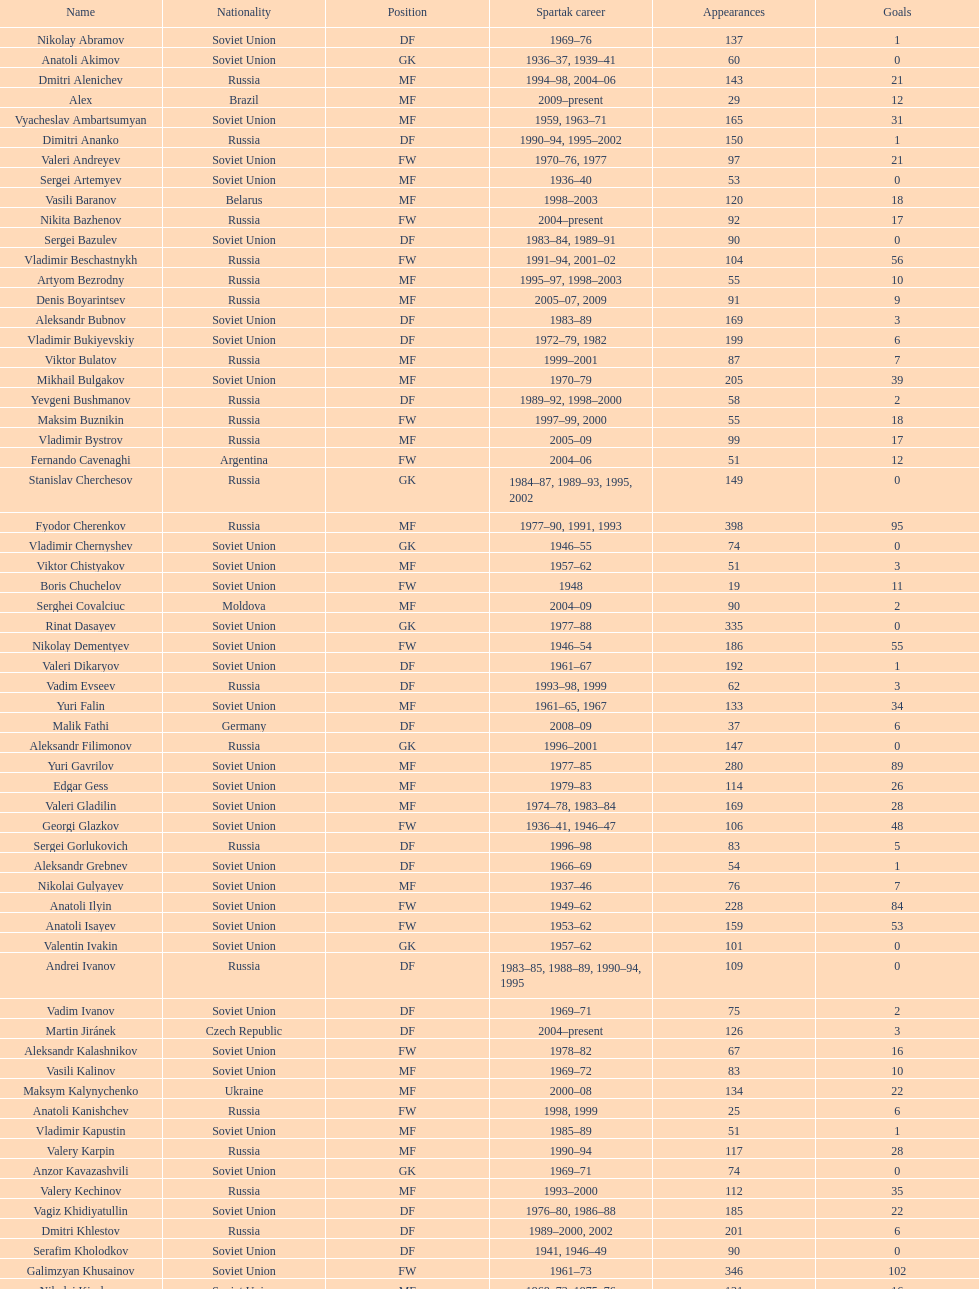Would you mind parsing the complete table? {'header': ['Name', 'Nationality', 'Position', 'Spartak career', 'Appearances', 'Goals'], 'rows': [['Nikolay Abramov', 'Soviet Union', 'DF', '1969–76', '137', '1'], ['Anatoli Akimov', 'Soviet Union', 'GK', '1936–37, 1939–41', '60', '0'], ['Dmitri Alenichev', 'Russia', 'MF', '1994–98, 2004–06', '143', '21'], ['Alex', 'Brazil', 'MF', '2009–present', '29', '12'], ['Vyacheslav Ambartsumyan', 'Soviet Union', 'MF', '1959, 1963–71', '165', '31'], ['Dimitri Ananko', 'Russia', 'DF', '1990–94, 1995–2002', '150', '1'], ['Valeri Andreyev', 'Soviet Union', 'FW', '1970–76, 1977', '97', '21'], ['Sergei Artemyev', 'Soviet Union', 'MF', '1936–40', '53', '0'], ['Vasili Baranov', 'Belarus', 'MF', '1998–2003', '120', '18'], ['Nikita Bazhenov', 'Russia', 'FW', '2004–present', '92', '17'], ['Sergei Bazulev', 'Soviet Union', 'DF', '1983–84, 1989–91', '90', '0'], ['Vladimir Beschastnykh', 'Russia', 'FW', '1991–94, 2001–02', '104', '56'], ['Artyom Bezrodny', 'Russia', 'MF', '1995–97, 1998–2003', '55', '10'], ['Denis Boyarintsev', 'Russia', 'MF', '2005–07, 2009', '91', '9'], ['Aleksandr Bubnov', 'Soviet Union', 'DF', '1983–89', '169', '3'], ['Vladimir Bukiyevskiy', 'Soviet Union', 'DF', '1972–79, 1982', '199', '6'], ['Viktor Bulatov', 'Russia', 'MF', '1999–2001', '87', '7'], ['Mikhail Bulgakov', 'Soviet Union', 'MF', '1970–79', '205', '39'], ['Yevgeni Bushmanov', 'Russia', 'DF', '1989–92, 1998–2000', '58', '2'], ['Maksim Buznikin', 'Russia', 'FW', '1997–99, 2000', '55', '18'], ['Vladimir Bystrov', 'Russia', 'MF', '2005–09', '99', '17'], ['Fernando Cavenaghi', 'Argentina', 'FW', '2004–06', '51', '12'], ['Stanislav Cherchesov', 'Russia', 'GK', '1984–87, 1989–93, 1995, 2002', '149', '0'], ['Fyodor Cherenkov', 'Russia', 'MF', '1977–90, 1991, 1993', '398', '95'], ['Vladimir Chernyshev', 'Soviet Union', 'GK', '1946–55', '74', '0'], ['Viktor Chistyakov', 'Soviet Union', 'MF', '1957–62', '51', '3'], ['Boris Chuchelov', 'Soviet Union', 'FW', '1948', '19', '11'], ['Serghei Covalciuc', 'Moldova', 'MF', '2004–09', '90', '2'], ['Rinat Dasayev', 'Soviet Union', 'GK', '1977–88', '335', '0'], ['Nikolay Dementyev', 'Soviet Union', 'FW', '1946–54', '186', '55'], ['Valeri Dikaryov', 'Soviet Union', 'DF', '1961–67', '192', '1'], ['Vadim Evseev', 'Russia', 'DF', '1993–98, 1999', '62', '3'], ['Yuri Falin', 'Soviet Union', 'MF', '1961–65, 1967', '133', '34'], ['Malik Fathi', 'Germany', 'DF', '2008–09', '37', '6'], ['Aleksandr Filimonov', 'Russia', 'GK', '1996–2001', '147', '0'], ['Yuri Gavrilov', 'Soviet Union', 'MF', '1977–85', '280', '89'], ['Edgar Gess', 'Soviet Union', 'MF', '1979–83', '114', '26'], ['Valeri Gladilin', 'Soviet Union', 'MF', '1974–78, 1983–84', '169', '28'], ['Georgi Glazkov', 'Soviet Union', 'FW', '1936–41, 1946–47', '106', '48'], ['Sergei Gorlukovich', 'Russia', 'DF', '1996–98', '83', '5'], ['Aleksandr Grebnev', 'Soviet Union', 'DF', '1966–69', '54', '1'], ['Nikolai Gulyayev', 'Soviet Union', 'MF', '1937–46', '76', '7'], ['Anatoli Ilyin', 'Soviet Union', 'FW', '1949–62', '228', '84'], ['Anatoli Isayev', 'Soviet Union', 'FW', '1953–62', '159', '53'], ['Valentin Ivakin', 'Soviet Union', 'GK', '1957–62', '101', '0'], ['Andrei Ivanov', 'Russia', 'DF', '1983–85, 1988–89, 1990–94, 1995', '109', '0'], ['Vadim Ivanov', 'Soviet Union', 'DF', '1969–71', '75', '2'], ['Martin Jiránek', 'Czech Republic', 'DF', '2004–present', '126', '3'], ['Aleksandr Kalashnikov', 'Soviet Union', 'FW', '1978–82', '67', '16'], ['Vasili Kalinov', 'Soviet Union', 'MF', '1969–72', '83', '10'], ['Maksym Kalynychenko', 'Ukraine', 'MF', '2000–08', '134', '22'], ['Anatoli Kanishchev', 'Russia', 'FW', '1998, 1999', '25', '6'], ['Vladimir Kapustin', 'Soviet Union', 'MF', '1985–89', '51', '1'], ['Valery Karpin', 'Russia', 'MF', '1990–94', '117', '28'], ['Anzor Kavazashvili', 'Soviet Union', 'GK', '1969–71', '74', '0'], ['Valery Kechinov', 'Russia', 'MF', '1993–2000', '112', '35'], ['Vagiz Khidiyatullin', 'Soviet Union', 'DF', '1976–80, 1986–88', '185', '22'], ['Dmitri Khlestov', 'Russia', 'DF', '1989–2000, 2002', '201', '6'], ['Serafim Kholodkov', 'Soviet Union', 'DF', '1941, 1946–49', '90', '0'], ['Galimzyan Khusainov', 'Soviet Union', 'FW', '1961–73', '346', '102'], ['Nikolai Kiselyov', 'Soviet Union', 'MF', '1968–73, 1975–76', '131', '16'], ['Aleksandr Kokorev', 'Soviet Union', 'MF', '1972–80', '90', '4'], ['Ivan Konov', 'Soviet Union', 'FW', '1945–48', '85', '31'], ['Viktor Konovalov', 'Soviet Union', 'MF', '1960–61', '24', '5'], ['Alexey Korneyev', 'Soviet Union', 'DF', '1957–67', '177', '0'], ['Pavel Kornilov', 'Soviet Union', 'FW', '1938–41', '65', '38'], ['Radoslav Kováč', 'Czech Republic', 'MF', '2005–08', '101', '9'], ['Yuri Kovtun', 'Russia', 'DF', '1999–2005', '122', '7'], ['Wojciech Kowalewski', 'Poland', 'GK', '2003–07', '94', '0'], ['Anatoly Krutikov', 'Soviet Union', 'DF', '1959–69', '269', '9'], ['Dmitri Kudryashov', 'Russia', 'MF', '2002', '22', '5'], ['Vasili Kulkov', 'Russia', 'DF', '1986, 1989–91, 1995, 1997', '93', '4'], ['Boris Kuznetsov', 'Soviet Union', 'DF', '1985–88, 1989–90', '90', '0'], ['Yevgeni Kuznetsov', 'Soviet Union', 'MF', '1982–89', '209', '23'], ['Igor Lediakhov', 'Russia', 'MF', '1992–94', '65', '21'], ['Aleksei Leontyev', 'Soviet Union', 'GK', '1940–49', '109', '0'], ['Boris Lobutev', 'Soviet Union', 'FW', '1957–60', '15', '7'], ['Gennady Logofet', 'Soviet Union', 'DF', '1960–75', '349', '27'], ['Evgeny Lovchev', 'Soviet Union', 'MF', '1969–78', '249', '30'], ['Konstantin Malinin', 'Soviet Union', 'DF', '1939–50', '140', '7'], ['Ramiz Mamedov', 'Russia', 'DF', '1991–98', '125', '6'], ['Valeri Masalitin', 'Russia', 'FW', '1994–95', '7', '5'], ['Vladimir Maslachenko', 'Soviet Union', 'GK', '1962–68', '196', '0'], ['Anatoli Maslyonkin', 'Soviet Union', 'DF', '1954–63', '216', '8'], ['Aleksei Melyoshin', 'Russia', 'MF', '1995–2000', '68', '5'], ['Aleksandr Minayev', 'Soviet Union', 'MF', '1972–75', '92', '10'], ['Alexander Mirzoyan', 'Soviet Union', 'DF', '1979–83', '80', '9'], ['Vitali Mirzoyev', 'Soviet Union', 'FW', '1971–74', '58', '4'], ['Viktor Mishin', 'Soviet Union', 'FW', '1956–61', '43', '8'], ['Igor Mitreski', 'Macedonia', 'DF', '2001–04', '85', '0'], ['Gennady Morozov', 'Soviet Union', 'DF', '1980–86, 1989–90', '196', '3'], ['Aleksandr Mostovoi', 'Soviet Union', 'MF', '1986–91', '106', '34'], ['Mozart', 'Brazil', 'MF', '2005–08', '68', '7'], ['Ivan Mozer', 'Soviet Union', 'MF', '1956–61', '96', '30'], ['Mukhsin Mukhamadiev', 'Russia', 'MF', '1994–95', '30', '13'], ['Igor Netto', 'Soviet Union', 'MF', '1949–66', '368', '36'], ['Yuriy Nikiforov', 'Russia', 'DF', '1993–96', '85', '16'], ['Vladimir Nikonov', 'Soviet Union', 'MF', '1979–80, 1982', '25', '5'], ['Sergei Novikov', 'Soviet Union', 'MF', '1978–80, 1985–89', '70', '12'], ['Mikhail Ogonkov', 'Soviet Union', 'DF', '1953–58, 1961', '78', '0'], ['Sergei Olshansky', 'Soviet Union', 'DF', '1969–75', '138', '7'], ['Viktor Onopko', 'Russia', 'DF', '1992–95', '108', '23'], ['Nikolai Osyanin', 'Soviet Union', 'DF', '1966–71, 1974–76', '248', '50'], ['Viktor Papayev', 'Soviet Union', 'MF', '1968–73, 1975–76', '174', '10'], ['Aleksei Paramonov', 'Soviet Union', 'MF', '1947–59', '264', '61'], ['Dmytro Parfenov', 'Ukraine', 'DF', '1998–2005', '125', '15'], ['Nikolai Parshin', 'Soviet Union', 'FW', '1949–58', '106', '36'], ['Viktor Pasulko', 'Soviet Union', 'MF', '1987–89', '75', '16'], ['Aleksandr Pavlenko', 'Russia', 'MF', '2001–07, 2008–09', '110', '11'], ['Vadim Pavlenko', 'Soviet Union', 'FW', '1977–78', '47', '16'], ['Roman Pavlyuchenko', 'Russia', 'FW', '2003–08', '141', '69'], ['Hennadiy Perepadenko', 'Ukraine', 'MF', '1990–91, 1992', '51', '6'], ['Boris Petrov', 'Soviet Union', 'FW', '1962', '18', '5'], ['Vladimir Petrov', 'Soviet Union', 'DF', '1959–71', '174', '5'], ['Andrei Piatnitski', 'Russia', 'MF', '1992–97', '100', '17'], ['Nikolai Pisarev', 'Russia', 'FW', '1992–95, 1998, 2000–01', '115', '32'], ['Aleksandr Piskaryov', 'Soviet Union', 'FW', '1971–75', '117', '33'], ['Mihajlo Pjanović', 'Serbia', 'FW', '2003–06', '48', '11'], ['Stipe Pletikosa', 'Croatia', 'GK', '2007–present', '63', '0'], ['Dmitri Popov', 'Russia', 'DF', '1989–93', '78', '7'], ['Boris Pozdnyakov', 'Soviet Union', 'DF', '1978–84, 1989–91', '145', '3'], ['Vladimir Pribylov', 'Soviet Union', 'FW', '1964–69', '35', '6'], ['Aleksandr Prokhorov', 'Soviet Union', 'GK', '1972–75, 1976–78', '143', '0'], ['Andrei Protasov', 'Soviet Union', 'FW', '1939–41', '32', '10'], ['Dmitri Radchenko', 'Russia', 'FW', '1991–93', '61', '27'], ['Vladimir Redin', 'Soviet Union', 'MF', '1970–74, 1976', '90', '12'], ['Valeri Reyngold', 'Soviet Union', 'FW', '1960–67', '176', '32'], ['Luis Robson', 'Brazil', 'FW', '1997–2001', '102', '32'], ['Sergey Rodionov', 'Russia', 'FW', '1979–90, 1993–95', '303', '124'], ['Clemente Rodríguez', 'Argentina', 'DF', '2004–06, 2008–09', '71', '3'], ['Oleg Romantsev', 'Soviet Union', 'DF', '1976–83', '180', '6'], ['Miroslav Romaschenko', 'Belarus', 'MF', '1997–98', '42', '7'], ['Sergei Rozhkov', 'Soviet Union', 'MF', '1961–65, 1967–69, 1974', '143', '8'], ['Andrei Rudakov', 'Soviet Union', 'FW', '1985–87', '49', '17'], ['Leonid Rumyantsev', 'Soviet Union', 'FW', '1936–40', '26', '8'], ['Mikhail Rusyayev', 'Russia', 'FW', '1981–87, 1992', '47', '9'], ['Konstantin Ryazantsev', 'Soviet Union', 'MF', '1941, 1944–51', '114', '5'], ['Aleksandr Rystsov', 'Soviet Union', 'FW', '1947–54', '100', '16'], ['Sergei Salnikov', 'Soviet Union', 'FW', '1946–49, 1955–60', '201', '64'], ['Aleksandr Samedov', 'Russia', 'MF', '2001–05', '47', '6'], ['Viktor Samokhin', 'Soviet Union', 'MF', '1974–81', '188', '3'], ['Yuri Sedov', 'Soviet Union', 'DF', '1948–55, 1957–59', '176', '2'], ['Anatoli Seglin', 'Soviet Union', 'DF', '1945–52', '83', '0'], ['Viktor Semyonov', 'Soviet Union', 'FW', '1937–47', '104', '49'], ['Yuri Sevidov', 'Soviet Union', 'FW', '1960–65', '146', '54'], ['Igor Shalimov', 'Russia', 'MF', '1986–91', '95', '20'], ['Sergey Shavlo', 'Soviet Union', 'MF', '1977–82, 1984–85', '256', '48'], ['Aleksandr Shirko', 'Russia', 'FW', '1993–2001', '128', '40'], ['Roman Shishkin', 'Russia', 'DF', '2003–08', '54', '1'], ['Valeri Shmarov', 'Russia', 'FW', '1987–91, 1995–96', '143', '54'], ['Sergei Shvetsov', 'Soviet Union', 'DF', '1981–84', '68', '14'], ['Yevgeni Sidorov', 'Soviet Union', 'MF', '1974–81, 1984–85', '191', '18'], ['Dzhemal Silagadze', 'Soviet Union', 'FW', '1968–71, 1973', '91', '12'], ['Nikita Simonyan', 'Soviet Union', 'FW', '1949–59', '215', '135'], ['Boris Smyslov', 'Soviet Union', 'FW', '1945–48', '45', '6'], ['Florin Şoavă', 'Romania', 'DF', '2004–05, 2007–08', '52', '1'], ['Vladimir Sochnov', 'Soviet Union', 'DF', '1981–85, 1989', '148', '9'], ['Aleksei Sokolov', 'Soviet Union', 'FW', '1938–41, 1942, 1944–47', '114', '49'], ['Vasili Sokolov', 'Soviet Union', 'DF', '1938–41, 1942–51', '262', '2'], ['Viktor Sokolov', 'Soviet Union', 'DF', '1936–41, 1942–46', '121', '0'], ['Anatoli Soldatov', 'Soviet Union', 'DF', '1958–65', '113', '1'], ['Aleksandr Sorokin', 'Soviet Union', 'MF', '1977–80', '107', '9'], ['Andrei Starostin', 'Soviet Union', 'MF', '1936–40', '95', '4'], ['Vladimir Stepanov', 'Soviet Union', 'FW', '1936–41, 1942', '101', '33'], ['Andrejs Štolcers', 'Latvia', 'MF', '2000', '11', '5'], ['Martin Stranzl', 'Austria', 'DF', '2006–present', '80', '3'], ['Yuri Susloparov', 'Soviet Union', 'DF', '1986–90', '80', '1'], ['Yuri Syomin', 'Soviet Union', 'MF', '1965–67', '43', '6'], ['Dmitri Sychev', 'Russia', 'FW', '2002', '18', '9'], ['Boris Tatushin', 'Soviet Union', 'FW', '1953–58, 1961', '116', '38'], ['Viktor Terentyev', 'Soviet Union', 'FW', '1948–53', '103', '34'], ['Andrey Tikhonov', 'Russia', 'MF', '1992–2000', '191', '68'], ['Oleg Timakov', 'Soviet Union', 'MF', '1945–54', '182', '19'], ['Nikolai Tishchenko', 'Soviet Union', 'DF', '1951–58', '106', '0'], ['Yegor Titov', 'Russia', 'MF', '1992–2008', '324', '86'], ['Eduard Tsykhmeystruk', 'Ukraine', 'FW', '2001–02', '35', '5'], ['Ilya Tsymbalar', 'Russia', 'MF', '1993–99', '146', '42'], ['Grigori Tuchkov', 'Soviet Union', 'DF', '1937–41, 1942, 1944', '74', '2'], ['Vladas Tučkus', 'Soviet Union', 'GK', '1954–57', '60', '0'], ['Ivan Varlamov', 'Soviet Union', 'DF', '1964–68', '75', '0'], ['Welliton', 'Brazil', 'FW', '2007–present', '77', '51'], ['Vladimir Yanishevskiy', 'Soviet Union', 'FW', '1965–66', '46', '7'], ['Vladimir Yankin', 'Soviet Union', 'MF', '1966–70', '93', '19'], ['Georgi Yartsev', 'Soviet Union', 'FW', '1977–80', '116', '55'], ['Valentin Yemyshev', 'Soviet Union', 'FW', '1948–53', '23', '9'], ['Aleksei Yeryomenko', 'Soviet Union', 'MF', '1986–87', '26', '5'], ['Viktor Yevlentyev', 'Soviet Union', 'MF', '1963–65, 1967–70', '56', '11'], ['Sergei Yuran', 'Russia', 'FW', '1995, 1999', '26', '5'], ['Valeri Zenkov', 'Soviet Union', 'DF', '1971–74', '59', '1']]} Name two players with goals above 15. Dmitri Alenichev, Vyacheslav Ambartsumyan. 